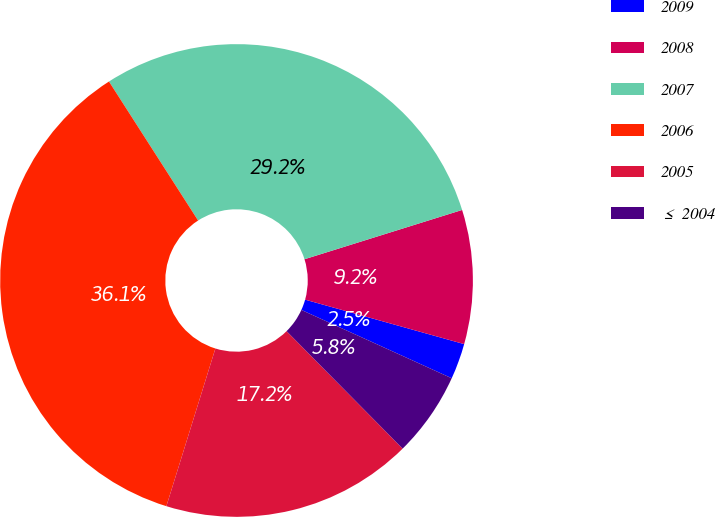Convert chart. <chart><loc_0><loc_0><loc_500><loc_500><pie_chart><fcel>2009<fcel>2008<fcel>2007<fcel>2006<fcel>2005<fcel>≤ 2004<nl><fcel>2.45%<fcel>9.16%<fcel>29.25%<fcel>36.13%<fcel>17.2%<fcel>5.81%<nl></chart> 